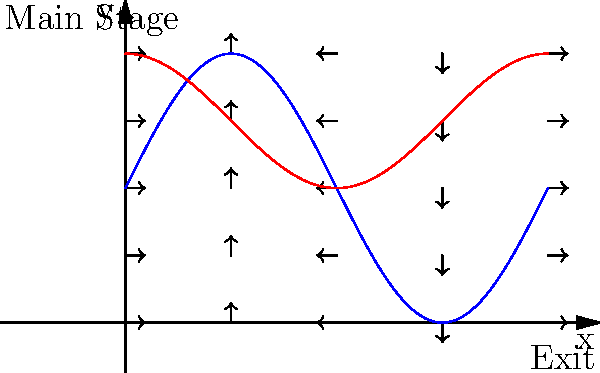As an event organizer, you're analyzing crowd flow in a rectangular venue. The blue curve represents the main stage area, and the red curve represents a popular food court. Vector fields indicate crowd movement. Where is congestion most likely to occur, and how would you mitigate it? To analyze the crowd flow and identify congestion points:

1. Observe the vector field:
   - Vectors show direction and magnitude of crowd movement.
   - Longer vectors indicate faster movement, shorter vectors indicate slower movement.

2. Identify critical points:
   - The intersection of the blue (main stage) and red (food court) curves at approximately $$(x, y) = (1.5, 3)$$ is a potential congestion point.
   - This area has shorter vectors, indicating slower movement.

3. Analyze crowd behavior:
   - People tend to gather near the main stage (blue curve) and food court (red curve).
   - The area between these attractions will experience high traffic.

4. Consider entry/exit points:
   - The exit is located at the bottom right, creating a natural flow towards that direction.

5. Mitigation strategies:
   - Widen pathways between the main stage and food court.
   - Implement one-way traffic flow systems in high-congestion areas.
   - Place staff or signs to direct crowd movement efficiently.
   - Consider relocating some food vendors to spread out the crowd.
   - Use barriers or temporary structures to guide crowd flow.

6. Monitor and adjust:
   - Use real-time crowd monitoring systems to identify and respond to congestion quickly.
   - Be prepared to make on-the-spot adjustments to crowd control measures.

By implementing these strategies, you can minimize congestion and improve overall crowd flow, enhancing the event experience and safety.
Answer: Congestion likely at $$(1.5, 3)$$; mitigate by widening pathways, implementing one-way traffic, strategic vendor placement, and real-time monitoring. 